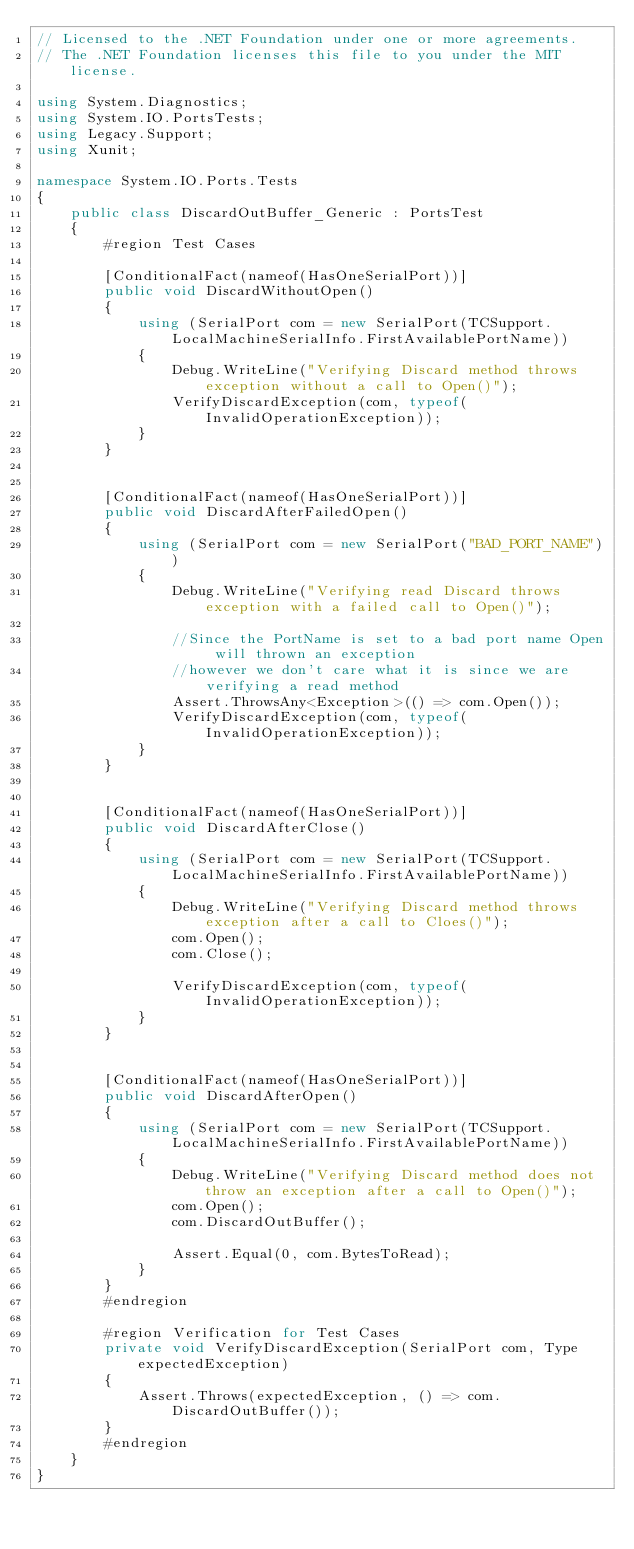<code> <loc_0><loc_0><loc_500><loc_500><_C#_>// Licensed to the .NET Foundation under one or more agreements.
// The .NET Foundation licenses this file to you under the MIT license.

using System.Diagnostics;
using System.IO.PortsTests;
using Legacy.Support;
using Xunit;

namespace System.IO.Ports.Tests
{
    public class DiscardOutBuffer_Generic : PortsTest
    {
        #region Test Cases

        [ConditionalFact(nameof(HasOneSerialPort))]
        public void DiscardWithoutOpen()
        {
            using (SerialPort com = new SerialPort(TCSupport.LocalMachineSerialInfo.FirstAvailablePortName))
            {
                Debug.WriteLine("Verifying Discard method throws exception without a call to Open()");
                VerifyDiscardException(com, typeof(InvalidOperationException));
            }
        }


        [ConditionalFact(nameof(HasOneSerialPort))]
        public void DiscardAfterFailedOpen()
        {
            using (SerialPort com = new SerialPort("BAD_PORT_NAME"))
            {
                Debug.WriteLine("Verifying read Discard throws exception with a failed call to Open()");

                //Since the PortName is set to a bad port name Open will thrown an exception
                //however we don't care what it is since we are verifying a read method
                Assert.ThrowsAny<Exception>(() => com.Open());
                VerifyDiscardException(com, typeof(InvalidOperationException));
            }
        }


        [ConditionalFact(nameof(HasOneSerialPort))]
        public void DiscardAfterClose()
        {
            using (SerialPort com = new SerialPort(TCSupport.LocalMachineSerialInfo.FirstAvailablePortName))
            {
                Debug.WriteLine("Verifying Discard method throws exception after a call to Cloes()");
                com.Open();
                com.Close();

                VerifyDiscardException(com, typeof(InvalidOperationException));
            }
        }


        [ConditionalFact(nameof(HasOneSerialPort))]
        public void DiscardAfterOpen()
        {
            using (SerialPort com = new SerialPort(TCSupport.LocalMachineSerialInfo.FirstAvailablePortName))
            {
                Debug.WriteLine("Verifying Discard method does not throw an exception after a call to Open()");
                com.Open();
                com.DiscardOutBuffer();

                Assert.Equal(0, com.BytesToRead);
            }
        }
        #endregion

        #region Verification for Test Cases
        private void VerifyDiscardException(SerialPort com, Type expectedException)
        {
            Assert.Throws(expectedException, () => com.DiscardOutBuffer());
        }
        #endregion
    }
}
</code> 